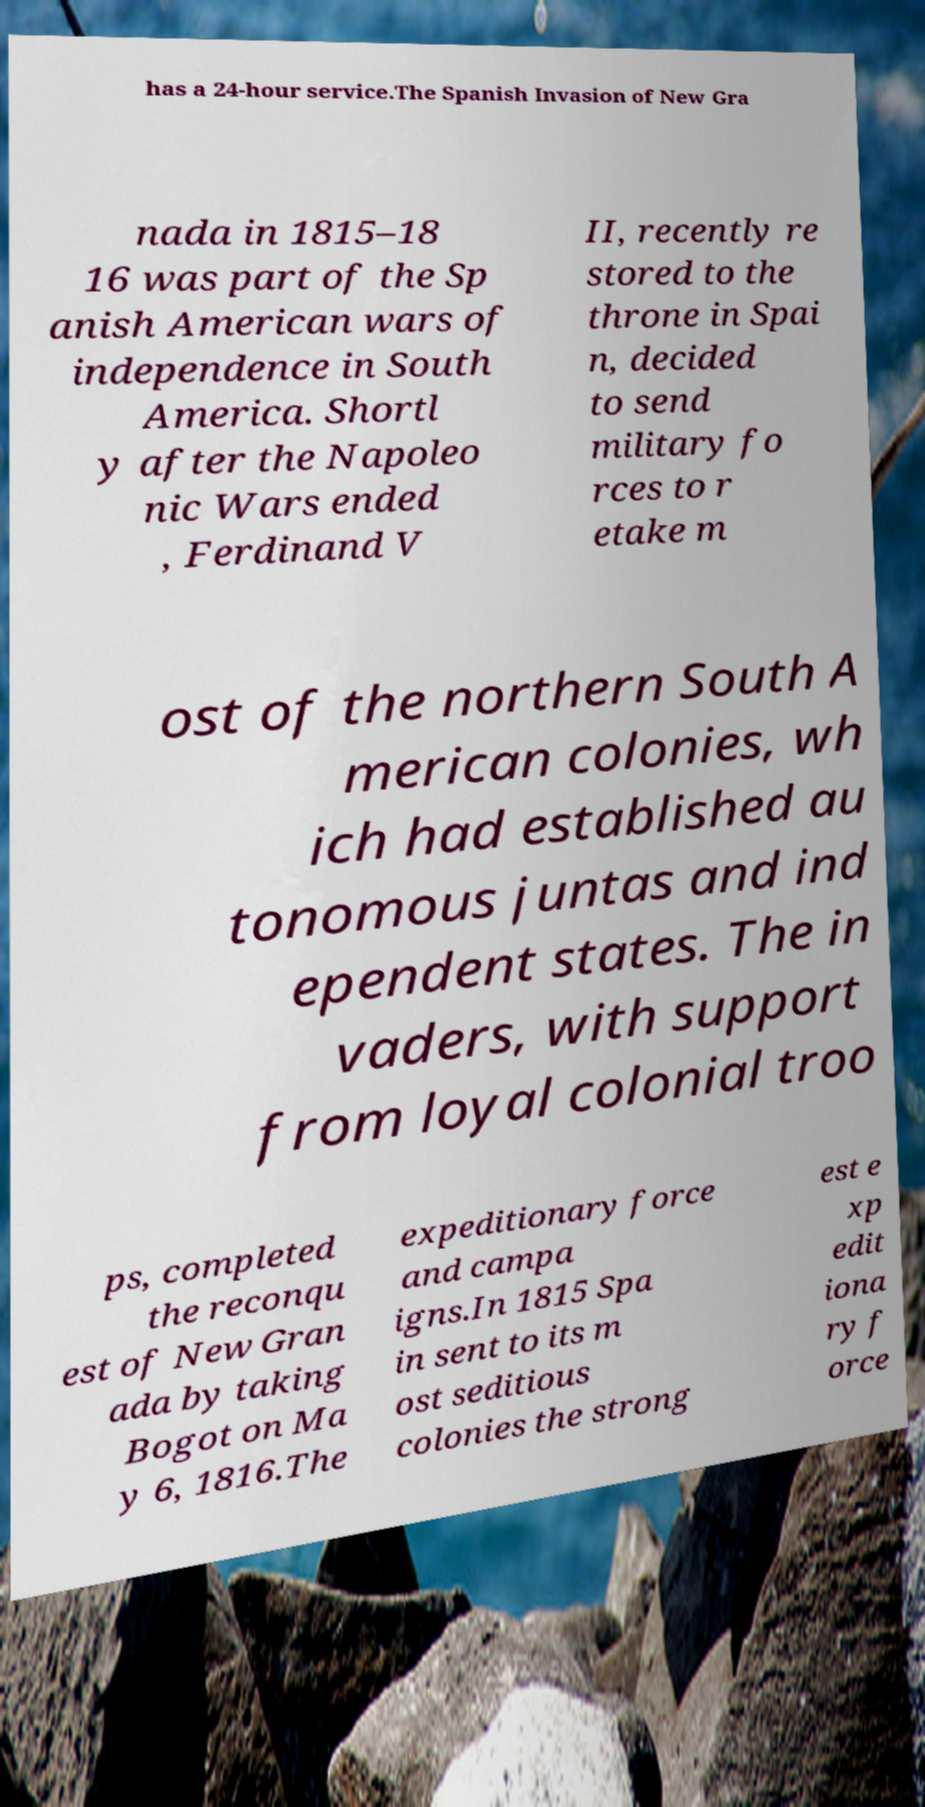Please identify and transcribe the text found in this image. has a 24-hour service.The Spanish Invasion of New Gra nada in 1815–18 16 was part of the Sp anish American wars of independence in South America. Shortl y after the Napoleo nic Wars ended , Ferdinand V II, recently re stored to the throne in Spai n, decided to send military fo rces to r etake m ost of the northern South A merican colonies, wh ich had established au tonomous juntas and ind ependent states. The in vaders, with support from loyal colonial troo ps, completed the reconqu est of New Gran ada by taking Bogot on Ma y 6, 1816.The expeditionary force and campa igns.In 1815 Spa in sent to its m ost seditious colonies the strong est e xp edit iona ry f orce 